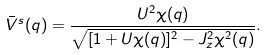Convert formula to latex. <formula><loc_0><loc_0><loc_500><loc_500>\bar { V } ^ { s } ( q ) = \frac { U ^ { 2 } \chi ( q ) } { \sqrt { [ 1 + U \chi ( q ) ] ^ { 2 } - J ^ { 2 } _ { z } \chi ^ { 2 } ( q ) } } .</formula> 